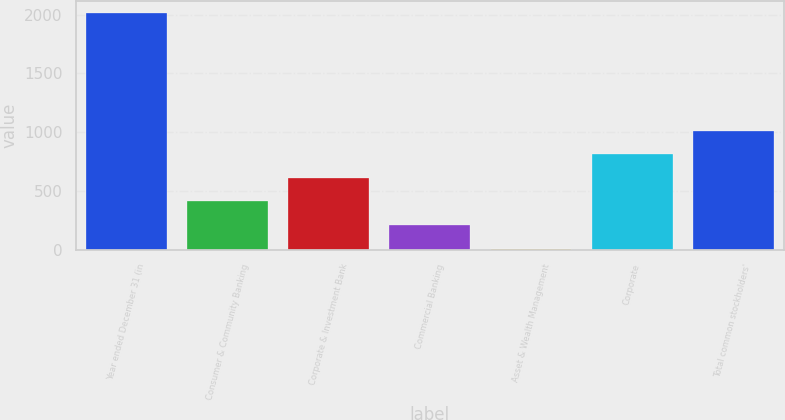Convert chart. <chart><loc_0><loc_0><loc_500><loc_500><bar_chart><fcel>Year ended December 31 (in<fcel>Consumer & Community Banking<fcel>Corporate & Investment Bank<fcel>Commercial Banking<fcel>Asset & Wealth Management<fcel>Corporate<fcel>Total common stockholders'<nl><fcel>2016<fcel>410.4<fcel>611.1<fcel>209.7<fcel>9<fcel>811.8<fcel>1012.5<nl></chart> 